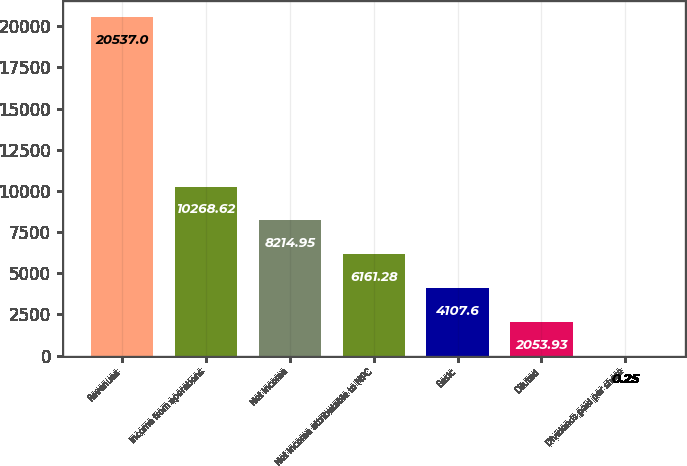Convert chart. <chart><loc_0><loc_0><loc_500><loc_500><bar_chart><fcel>Revenues<fcel>Income from operations<fcel>Net income<fcel>Net income attributable to MPC<fcel>Basic<fcel>Diluted<fcel>Dividends paid per share<nl><fcel>20537<fcel>10268.6<fcel>8214.95<fcel>6161.28<fcel>4107.6<fcel>2053.93<fcel>0.25<nl></chart> 